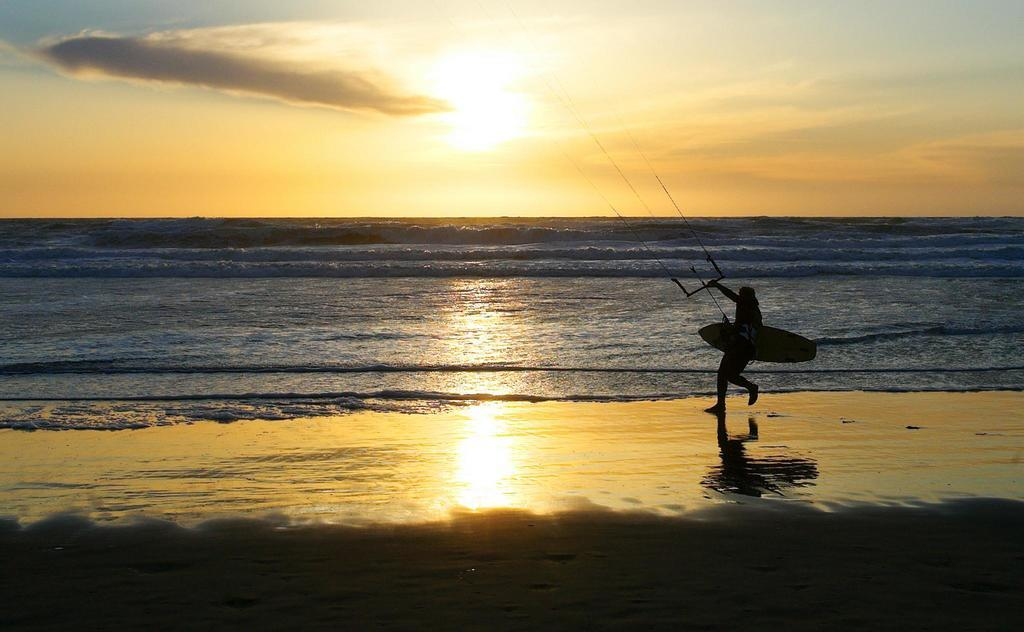Who is present in the image? There is a person in the image. Where is the person located? The person is on the sea shore. What is the person holding? The person is holding a skateboard. Can you describe the unspecified object in the image? Unfortunately, the facts provided do not give any details about the unspecified object. What natural feature can be seen in the background of the image? The ocean is visible in the image. What is happening with the sun in the image? The sun is setting in the image. How would you describe the sky in the image? The sky is clouded in the image. How many trucks are visible in the image? There are no trucks present in the image. What type of pain is the person experiencing in the image? There is no indication of pain in the image; the person is simply standing on the sea shore holding a skateboard. 